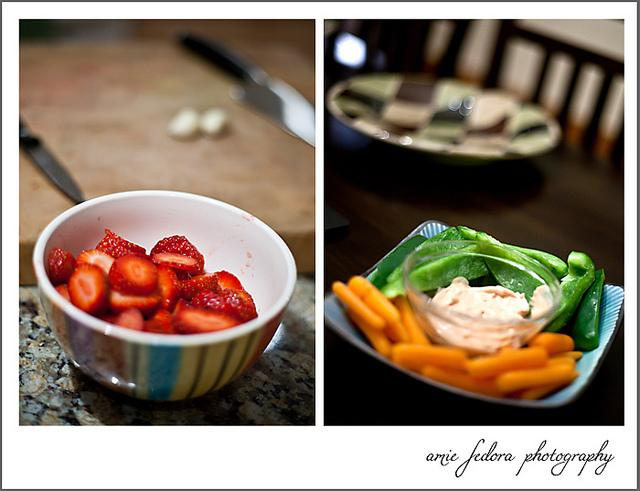What is in the bowl on the left? Please explain your reasoning. strawberries. The bowl has berries. 